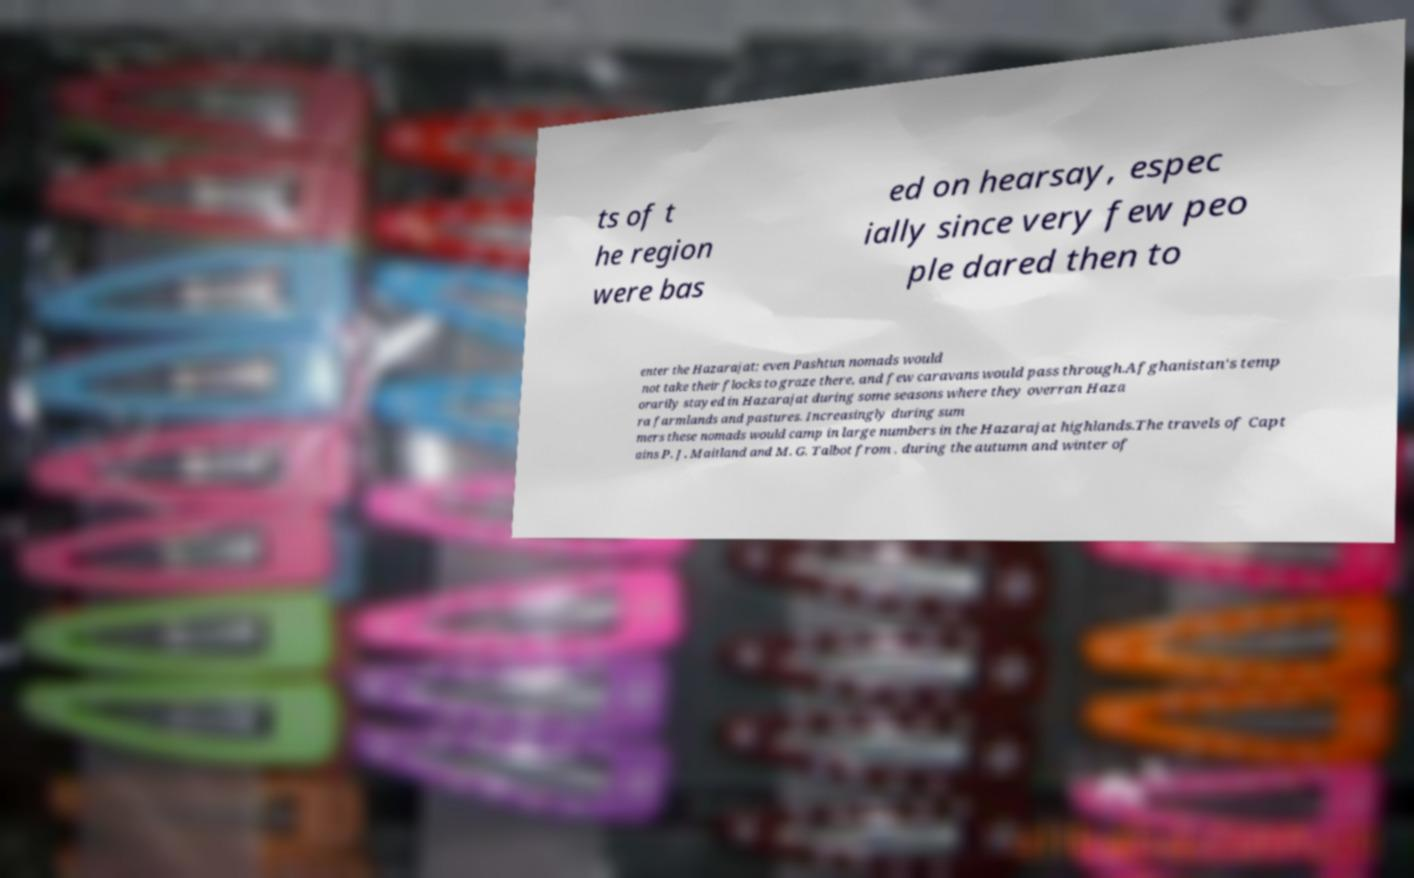Can you read and provide the text displayed in the image?This photo seems to have some interesting text. Can you extract and type it out for me? ts of t he region were bas ed on hearsay, espec ially since very few peo ple dared then to enter the Hazarajat; even Pashtun nomads would not take their flocks to graze there, and few caravans would pass through.Afghanistan's temp orarily stayed in Hazarajat during some seasons where they overran Haza ra farmlands and pastures. Increasingly during sum mers these nomads would camp in large numbers in the Hazarajat highlands.The travels of Capt ains P. J. Maitland and M. G. Talbot from , during the autumn and winter of 